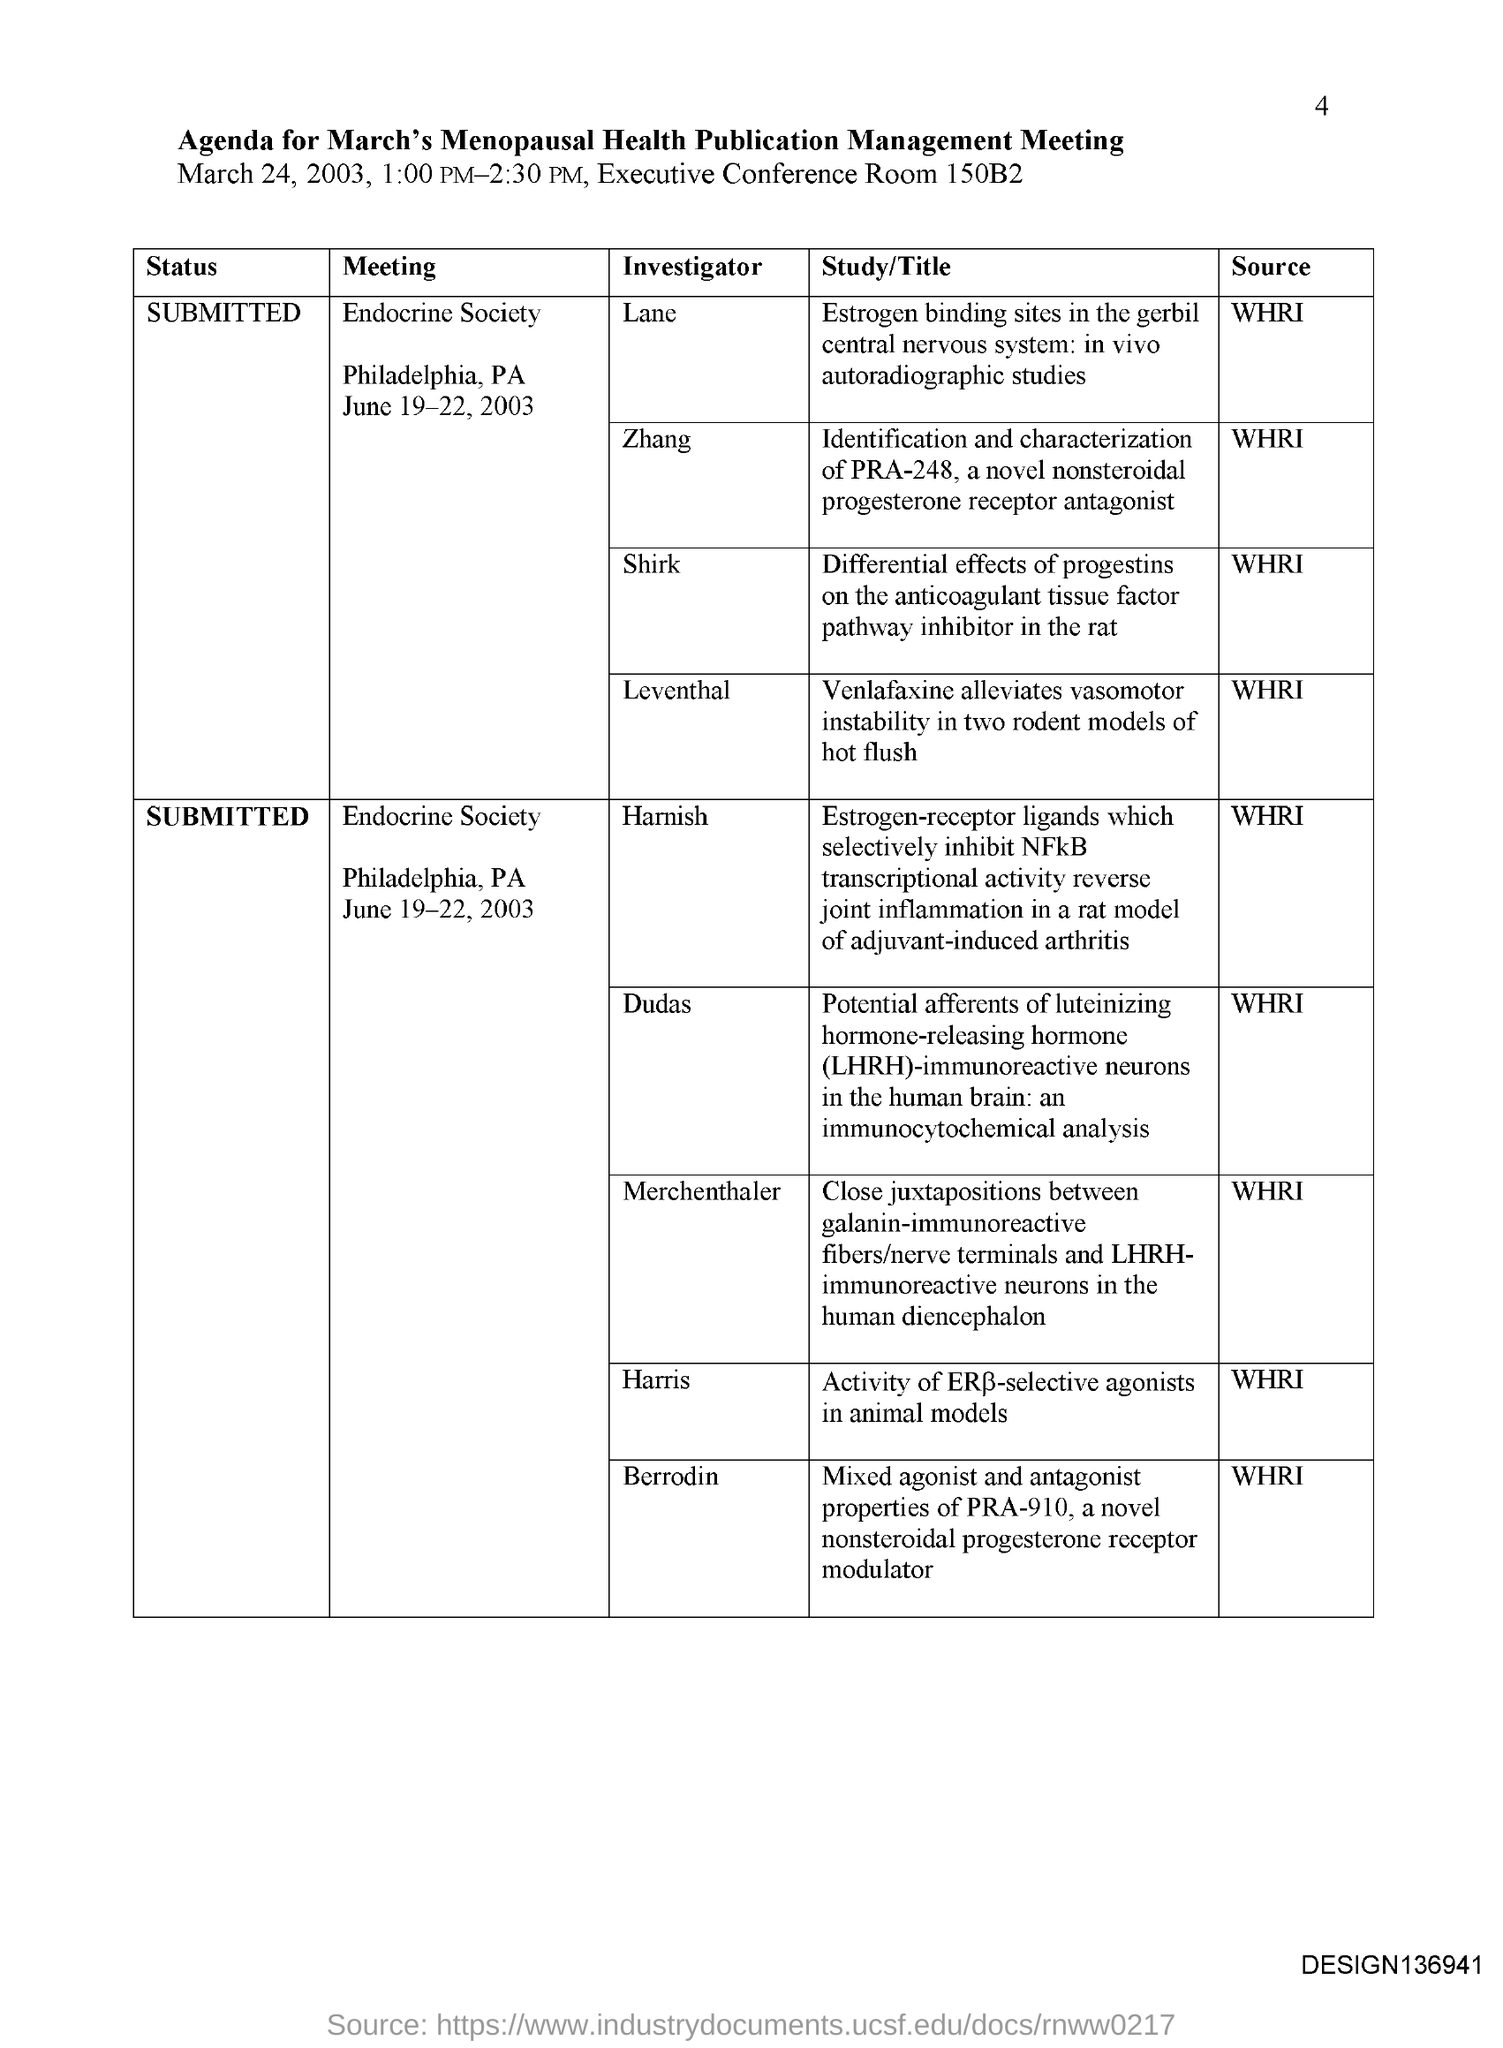Highlight a few significant elements in this photo. The meeting will take place on March 24, 2003 from 1:00 PM to 2:30 PM. The meeting was held in the Executive Conference Room, number 150B2. The agenda for the March meeting of the Menopausal Health Publication Management group is to discuss and manage the publications related to menopausal health. The date of the meeting is March 24, 2003. 